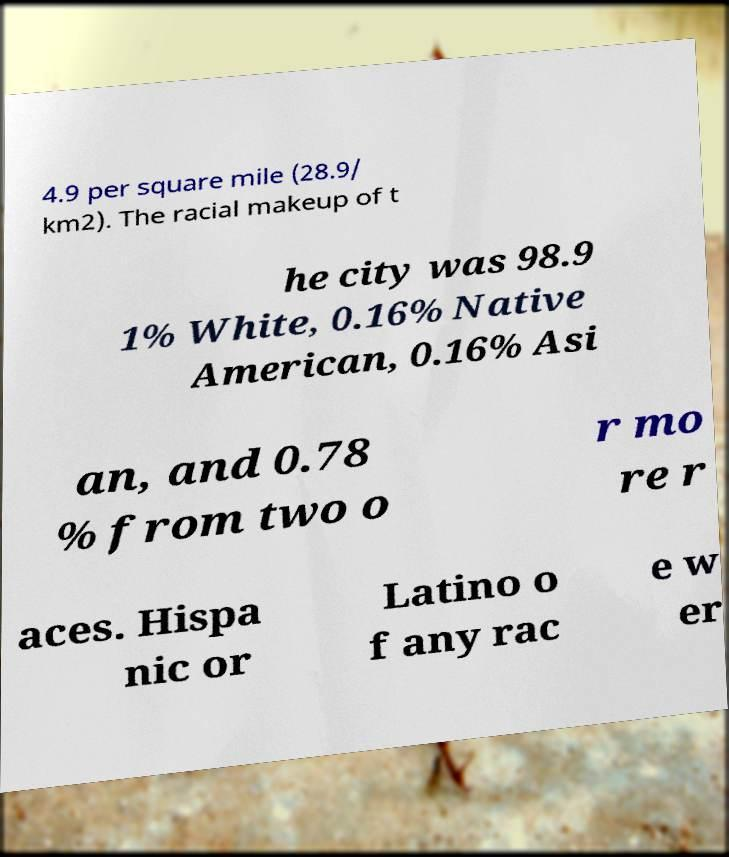What messages or text are displayed in this image? I need them in a readable, typed format. 4.9 per square mile (28.9/ km2). The racial makeup of t he city was 98.9 1% White, 0.16% Native American, 0.16% Asi an, and 0.78 % from two o r mo re r aces. Hispa nic or Latino o f any rac e w er 